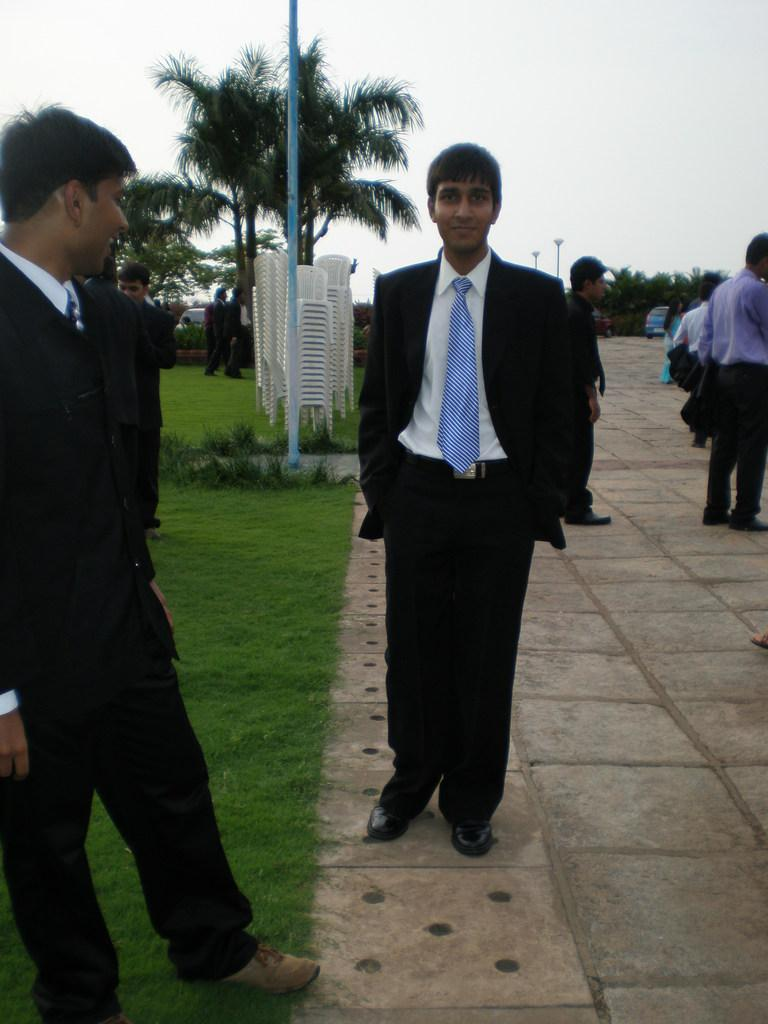What type of vegetation is present in the image? There is grass and trees in the image. What type of furniture can be seen in the image? There are chairs in the image. Are there any people in the image? Yes, there are people in the image. What is visible in the background of the image? The sky is visible in the image. What type of juice is being served in the image? There is no juice present in the image. Is there a gun visible in the image? No, there is no gun present in the image. 